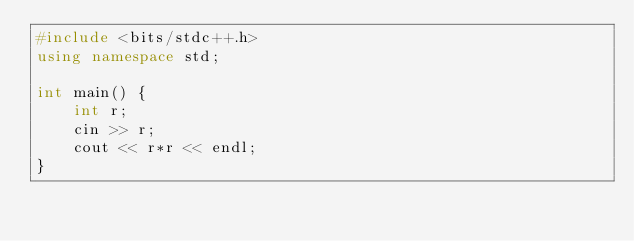Convert code to text. <code><loc_0><loc_0><loc_500><loc_500><_C++_>#include <bits/stdc++.h>
using namespace std;

int main() {
	int r;
    cin >> r;
    cout << r*r << endl;
}
</code> 